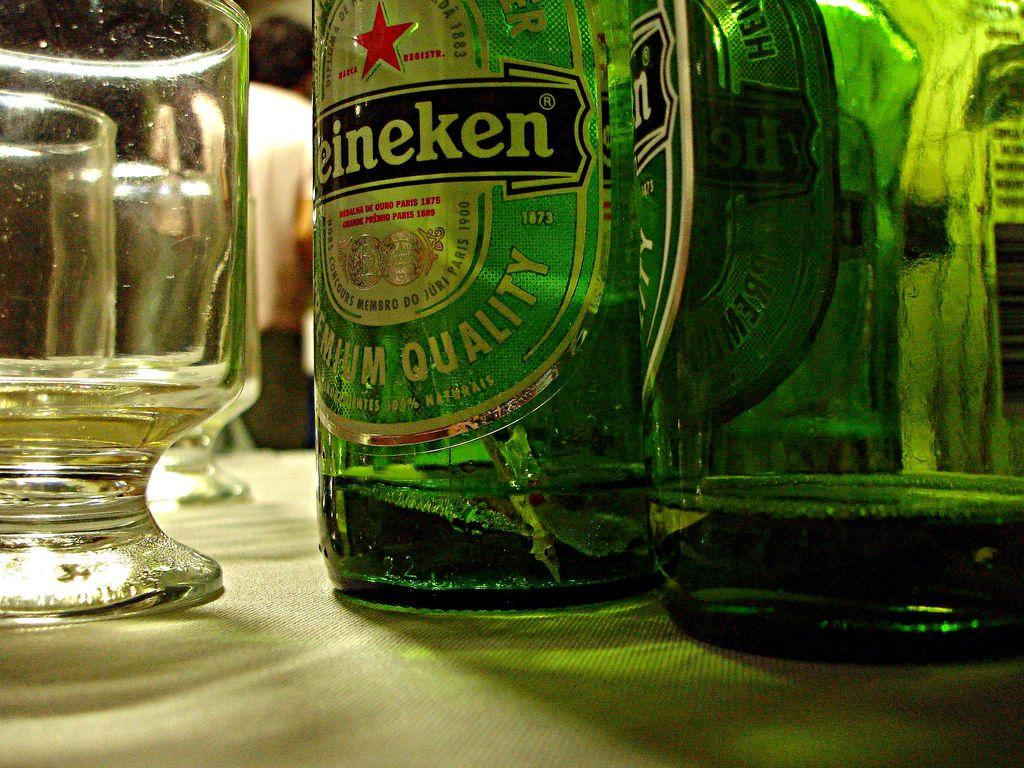<image>
Share a concise interpretation of the image provided. the word Heineken is on the green bottle 